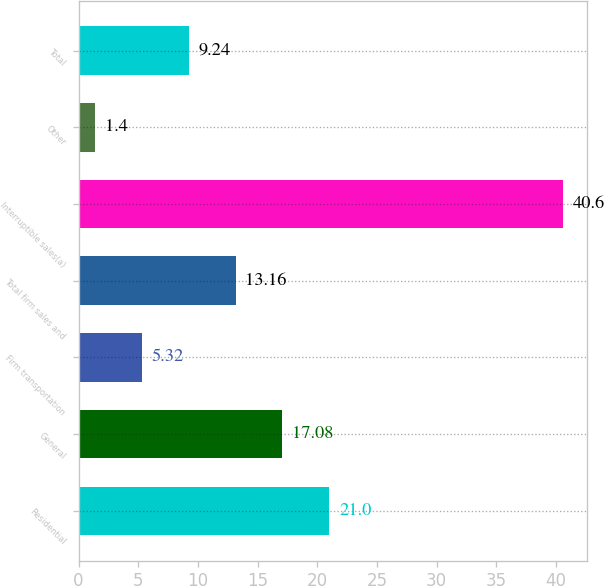Convert chart to OTSL. <chart><loc_0><loc_0><loc_500><loc_500><bar_chart><fcel>Residential<fcel>General<fcel>Firm transportation<fcel>Total firm sales and<fcel>Interruptible sales(a)<fcel>Other<fcel>Total<nl><fcel>21<fcel>17.08<fcel>5.32<fcel>13.16<fcel>40.6<fcel>1.4<fcel>9.24<nl></chart> 